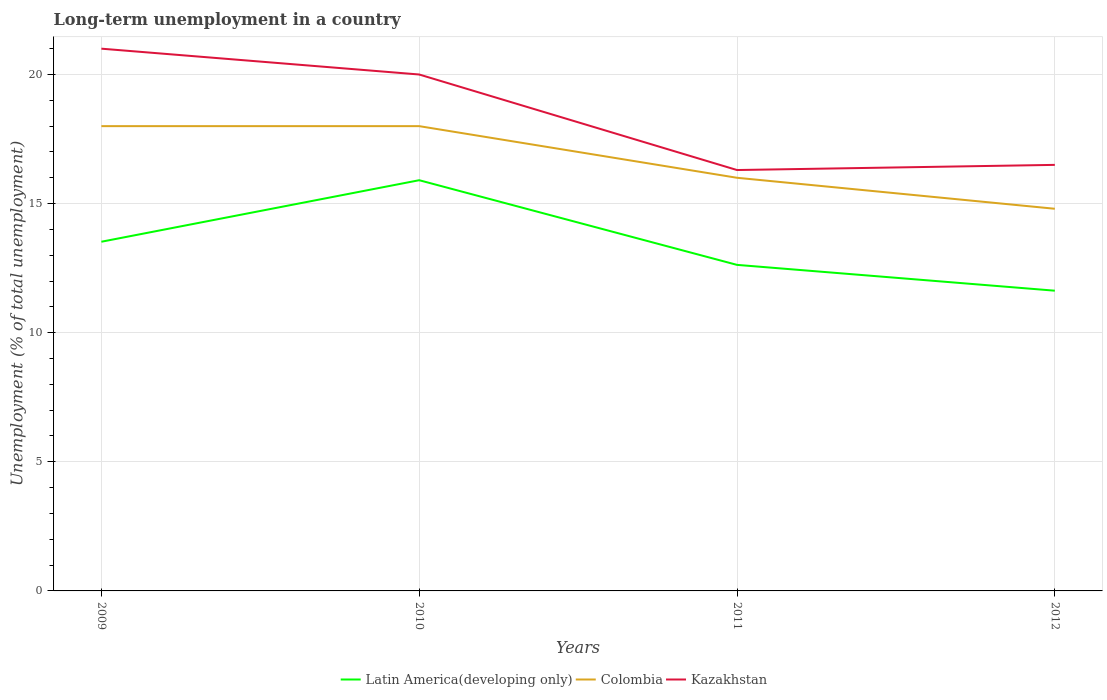Across all years, what is the maximum percentage of long-term unemployed population in Kazakhstan?
Your answer should be very brief. 16.3. In which year was the percentage of long-term unemployed population in Kazakhstan maximum?
Your answer should be compact. 2011. What is the total percentage of long-term unemployed population in Kazakhstan in the graph?
Make the answer very short. 3.7. What is the difference between the highest and the second highest percentage of long-term unemployed population in Kazakhstan?
Ensure brevity in your answer.  4.7. How many years are there in the graph?
Keep it short and to the point. 4. What is the difference between two consecutive major ticks on the Y-axis?
Give a very brief answer. 5. Are the values on the major ticks of Y-axis written in scientific E-notation?
Provide a short and direct response. No. Does the graph contain any zero values?
Provide a succinct answer. No. How many legend labels are there?
Your answer should be very brief. 3. How are the legend labels stacked?
Give a very brief answer. Horizontal. What is the title of the graph?
Make the answer very short. Long-term unemployment in a country. Does "Ghana" appear as one of the legend labels in the graph?
Your response must be concise. No. What is the label or title of the Y-axis?
Offer a very short reply. Unemployment (% of total unemployment). What is the Unemployment (% of total unemployment) of Latin America(developing only) in 2009?
Offer a terse response. 13.52. What is the Unemployment (% of total unemployment) in Latin America(developing only) in 2010?
Ensure brevity in your answer.  15.91. What is the Unemployment (% of total unemployment) in Colombia in 2010?
Your answer should be very brief. 18. What is the Unemployment (% of total unemployment) in Kazakhstan in 2010?
Keep it short and to the point. 20. What is the Unemployment (% of total unemployment) of Latin America(developing only) in 2011?
Give a very brief answer. 12.63. What is the Unemployment (% of total unemployment) of Kazakhstan in 2011?
Your answer should be compact. 16.3. What is the Unemployment (% of total unemployment) in Latin America(developing only) in 2012?
Your response must be concise. 11.63. What is the Unemployment (% of total unemployment) of Colombia in 2012?
Your answer should be compact. 14.8. What is the Unemployment (% of total unemployment) of Kazakhstan in 2012?
Offer a terse response. 16.5. Across all years, what is the maximum Unemployment (% of total unemployment) of Latin America(developing only)?
Your answer should be very brief. 15.91. Across all years, what is the maximum Unemployment (% of total unemployment) of Colombia?
Ensure brevity in your answer.  18. Across all years, what is the maximum Unemployment (% of total unemployment) of Kazakhstan?
Ensure brevity in your answer.  21. Across all years, what is the minimum Unemployment (% of total unemployment) in Latin America(developing only)?
Your answer should be very brief. 11.63. Across all years, what is the minimum Unemployment (% of total unemployment) of Colombia?
Provide a short and direct response. 14.8. Across all years, what is the minimum Unemployment (% of total unemployment) of Kazakhstan?
Your answer should be very brief. 16.3. What is the total Unemployment (% of total unemployment) of Latin America(developing only) in the graph?
Keep it short and to the point. 53.68. What is the total Unemployment (% of total unemployment) of Colombia in the graph?
Provide a short and direct response. 66.8. What is the total Unemployment (% of total unemployment) of Kazakhstan in the graph?
Give a very brief answer. 73.8. What is the difference between the Unemployment (% of total unemployment) in Latin America(developing only) in 2009 and that in 2010?
Provide a succinct answer. -2.38. What is the difference between the Unemployment (% of total unemployment) in Colombia in 2009 and that in 2010?
Offer a very short reply. 0. What is the difference between the Unemployment (% of total unemployment) in Latin America(developing only) in 2009 and that in 2011?
Your answer should be compact. 0.9. What is the difference between the Unemployment (% of total unemployment) in Kazakhstan in 2009 and that in 2011?
Give a very brief answer. 4.7. What is the difference between the Unemployment (% of total unemployment) in Latin America(developing only) in 2009 and that in 2012?
Ensure brevity in your answer.  1.9. What is the difference between the Unemployment (% of total unemployment) of Latin America(developing only) in 2010 and that in 2011?
Your answer should be very brief. 3.28. What is the difference between the Unemployment (% of total unemployment) in Latin America(developing only) in 2010 and that in 2012?
Offer a terse response. 4.28. What is the difference between the Unemployment (% of total unemployment) in Kazakhstan in 2010 and that in 2012?
Ensure brevity in your answer.  3.5. What is the difference between the Unemployment (% of total unemployment) in Latin America(developing only) in 2011 and that in 2012?
Offer a very short reply. 1. What is the difference between the Unemployment (% of total unemployment) in Colombia in 2011 and that in 2012?
Ensure brevity in your answer.  1.2. What is the difference between the Unemployment (% of total unemployment) in Latin America(developing only) in 2009 and the Unemployment (% of total unemployment) in Colombia in 2010?
Keep it short and to the point. -4.48. What is the difference between the Unemployment (% of total unemployment) in Latin America(developing only) in 2009 and the Unemployment (% of total unemployment) in Kazakhstan in 2010?
Your answer should be compact. -6.48. What is the difference between the Unemployment (% of total unemployment) in Latin America(developing only) in 2009 and the Unemployment (% of total unemployment) in Colombia in 2011?
Your answer should be compact. -2.48. What is the difference between the Unemployment (% of total unemployment) in Latin America(developing only) in 2009 and the Unemployment (% of total unemployment) in Kazakhstan in 2011?
Provide a succinct answer. -2.78. What is the difference between the Unemployment (% of total unemployment) in Latin America(developing only) in 2009 and the Unemployment (% of total unemployment) in Colombia in 2012?
Your answer should be compact. -1.28. What is the difference between the Unemployment (% of total unemployment) of Latin America(developing only) in 2009 and the Unemployment (% of total unemployment) of Kazakhstan in 2012?
Your response must be concise. -2.98. What is the difference between the Unemployment (% of total unemployment) of Colombia in 2009 and the Unemployment (% of total unemployment) of Kazakhstan in 2012?
Give a very brief answer. 1.5. What is the difference between the Unemployment (% of total unemployment) in Latin America(developing only) in 2010 and the Unemployment (% of total unemployment) in Colombia in 2011?
Offer a terse response. -0.09. What is the difference between the Unemployment (% of total unemployment) of Latin America(developing only) in 2010 and the Unemployment (% of total unemployment) of Kazakhstan in 2011?
Make the answer very short. -0.39. What is the difference between the Unemployment (% of total unemployment) of Latin America(developing only) in 2010 and the Unemployment (% of total unemployment) of Colombia in 2012?
Ensure brevity in your answer.  1.11. What is the difference between the Unemployment (% of total unemployment) in Latin America(developing only) in 2010 and the Unemployment (% of total unemployment) in Kazakhstan in 2012?
Your response must be concise. -0.59. What is the difference between the Unemployment (% of total unemployment) in Colombia in 2010 and the Unemployment (% of total unemployment) in Kazakhstan in 2012?
Your answer should be compact. 1.5. What is the difference between the Unemployment (% of total unemployment) of Latin America(developing only) in 2011 and the Unemployment (% of total unemployment) of Colombia in 2012?
Keep it short and to the point. -2.17. What is the difference between the Unemployment (% of total unemployment) of Latin America(developing only) in 2011 and the Unemployment (% of total unemployment) of Kazakhstan in 2012?
Provide a succinct answer. -3.87. What is the difference between the Unemployment (% of total unemployment) in Colombia in 2011 and the Unemployment (% of total unemployment) in Kazakhstan in 2012?
Your response must be concise. -0.5. What is the average Unemployment (% of total unemployment) of Latin America(developing only) per year?
Your answer should be compact. 13.42. What is the average Unemployment (% of total unemployment) of Colombia per year?
Ensure brevity in your answer.  16.7. What is the average Unemployment (% of total unemployment) in Kazakhstan per year?
Offer a very short reply. 18.45. In the year 2009, what is the difference between the Unemployment (% of total unemployment) in Latin America(developing only) and Unemployment (% of total unemployment) in Colombia?
Keep it short and to the point. -4.48. In the year 2009, what is the difference between the Unemployment (% of total unemployment) in Latin America(developing only) and Unemployment (% of total unemployment) in Kazakhstan?
Your response must be concise. -7.48. In the year 2010, what is the difference between the Unemployment (% of total unemployment) of Latin America(developing only) and Unemployment (% of total unemployment) of Colombia?
Offer a very short reply. -2.09. In the year 2010, what is the difference between the Unemployment (% of total unemployment) of Latin America(developing only) and Unemployment (% of total unemployment) of Kazakhstan?
Your answer should be compact. -4.09. In the year 2011, what is the difference between the Unemployment (% of total unemployment) of Latin America(developing only) and Unemployment (% of total unemployment) of Colombia?
Provide a succinct answer. -3.37. In the year 2011, what is the difference between the Unemployment (% of total unemployment) in Latin America(developing only) and Unemployment (% of total unemployment) in Kazakhstan?
Offer a terse response. -3.67. In the year 2012, what is the difference between the Unemployment (% of total unemployment) in Latin America(developing only) and Unemployment (% of total unemployment) in Colombia?
Your response must be concise. -3.17. In the year 2012, what is the difference between the Unemployment (% of total unemployment) in Latin America(developing only) and Unemployment (% of total unemployment) in Kazakhstan?
Your response must be concise. -4.87. In the year 2012, what is the difference between the Unemployment (% of total unemployment) of Colombia and Unemployment (% of total unemployment) of Kazakhstan?
Make the answer very short. -1.7. What is the ratio of the Unemployment (% of total unemployment) in Latin America(developing only) in 2009 to that in 2010?
Provide a short and direct response. 0.85. What is the ratio of the Unemployment (% of total unemployment) in Kazakhstan in 2009 to that in 2010?
Give a very brief answer. 1.05. What is the ratio of the Unemployment (% of total unemployment) of Latin America(developing only) in 2009 to that in 2011?
Keep it short and to the point. 1.07. What is the ratio of the Unemployment (% of total unemployment) in Kazakhstan in 2009 to that in 2011?
Keep it short and to the point. 1.29. What is the ratio of the Unemployment (% of total unemployment) of Latin America(developing only) in 2009 to that in 2012?
Offer a very short reply. 1.16. What is the ratio of the Unemployment (% of total unemployment) in Colombia in 2009 to that in 2012?
Your response must be concise. 1.22. What is the ratio of the Unemployment (% of total unemployment) of Kazakhstan in 2009 to that in 2012?
Make the answer very short. 1.27. What is the ratio of the Unemployment (% of total unemployment) of Latin America(developing only) in 2010 to that in 2011?
Ensure brevity in your answer.  1.26. What is the ratio of the Unemployment (% of total unemployment) in Kazakhstan in 2010 to that in 2011?
Your answer should be very brief. 1.23. What is the ratio of the Unemployment (% of total unemployment) in Latin America(developing only) in 2010 to that in 2012?
Make the answer very short. 1.37. What is the ratio of the Unemployment (% of total unemployment) of Colombia in 2010 to that in 2012?
Provide a succinct answer. 1.22. What is the ratio of the Unemployment (% of total unemployment) in Kazakhstan in 2010 to that in 2012?
Your answer should be compact. 1.21. What is the ratio of the Unemployment (% of total unemployment) of Latin America(developing only) in 2011 to that in 2012?
Offer a very short reply. 1.09. What is the ratio of the Unemployment (% of total unemployment) of Colombia in 2011 to that in 2012?
Keep it short and to the point. 1.08. What is the ratio of the Unemployment (% of total unemployment) of Kazakhstan in 2011 to that in 2012?
Your response must be concise. 0.99. What is the difference between the highest and the second highest Unemployment (% of total unemployment) of Latin America(developing only)?
Keep it short and to the point. 2.38. What is the difference between the highest and the second highest Unemployment (% of total unemployment) of Colombia?
Ensure brevity in your answer.  0. What is the difference between the highest and the second highest Unemployment (% of total unemployment) in Kazakhstan?
Offer a terse response. 1. What is the difference between the highest and the lowest Unemployment (% of total unemployment) of Latin America(developing only)?
Keep it short and to the point. 4.28. What is the difference between the highest and the lowest Unemployment (% of total unemployment) in Colombia?
Provide a short and direct response. 3.2. 